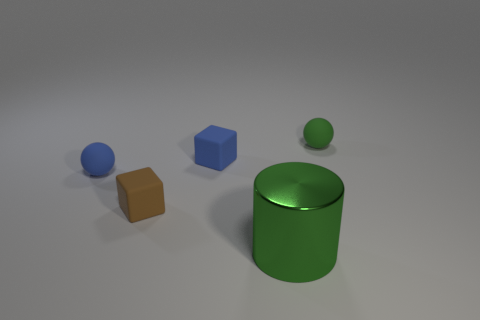Are there any other things that have the same shape as the brown object?
Give a very brief answer. Yes. Are there any tiny matte spheres of the same color as the cylinder?
Offer a very short reply. Yes. Does the sphere in front of the blue rubber block have the same material as the green thing that is in front of the small green matte object?
Offer a very short reply. No. The metallic thing has what color?
Provide a succinct answer. Green. How big is the cube that is in front of the small matte ball that is left of the tiny ball to the right of the blue rubber block?
Offer a very short reply. Small. What number of other objects are there of the same size as the blue matte sphere?
Your answer should be compact. 3. How many green balls are the same material as the large cylinder?
Ensure brevity in your answer.  0. There is a small object on the right side of the blue matte block; what is its shape?
Provide a short and direct response. Sphere. Are the green cylinder and the small ball to the right of the metal cylinder made of the same material?
Your answer should be compact. No. Are any big cyan metal objects visible?
Offer a very short reply. No. 